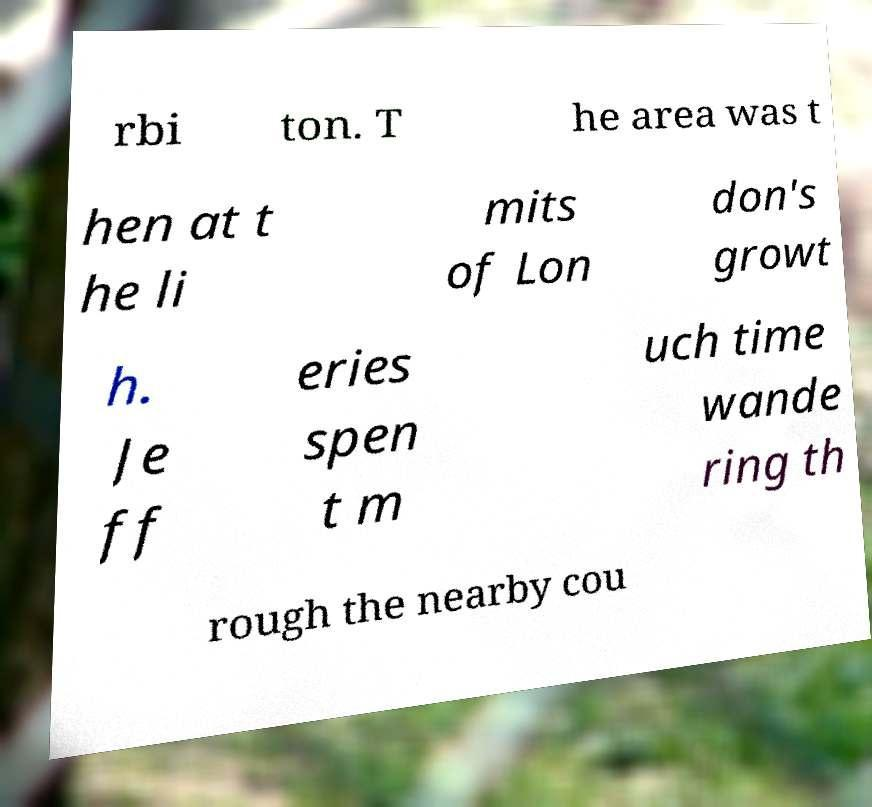Please identify and transcribe the text found in this image. rbi ton. T he area was t hen at t he li mits of Lon don's growt h. Je ff eries spen t m uch time wande ring th rough the nearby cou 